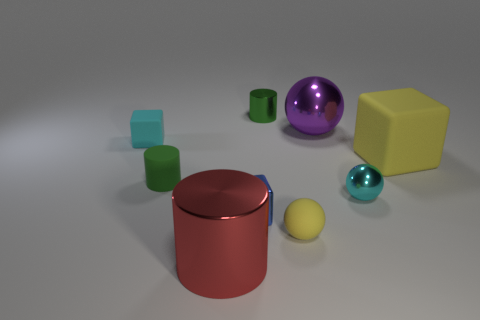Is there any other thing that has the same size as the green metal thing?
Your answer should be very brief. Yes. What size is the rubber object that is the same color as the large rubber cube?
Your answer should be very brief. Small. There is a small cube that is behind the large yellow matte cube; what material is it?
Offer a very short reply. Rubber. There is a metal cylinder that is in front of the tiny green metallic cylinder that is behind the rubber block on the left side of the purple metallic ball; what size is it?
Offer a very short reply. Large. Is the big thing behind the large rubber thing made of the same material as the cyan thing that is on the right side of the small yellow object?
Give a very brief answer. Yes. What number of other objects are there of the same color as the tiny rubber sphere?
Your answer should be very brief. 1. How many objects are either metal things behind the big cylinder or cyan matte things on the left side of the large purple object?
Offer a very short reply. 5. How big is the metallic cylinder behind the yellow matte object on the left side of the big yellow matte cube?
Ensure brevity in your answer.  Small. The purple object has what size?
Provide a succinct answer. Large. There is a tiny cylinder behind the purple shiny sphere; is it the same color as the tiny cylinder that is to the left of the blue shiny cube?
Ensure brevity in your answer.  Yes. 